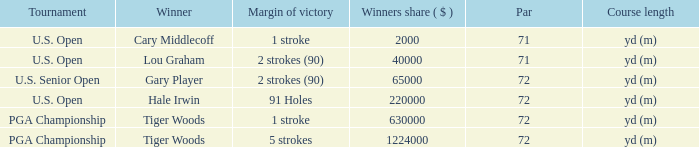When cary middlecoff wins, what is the total number of pars? 1.0. 